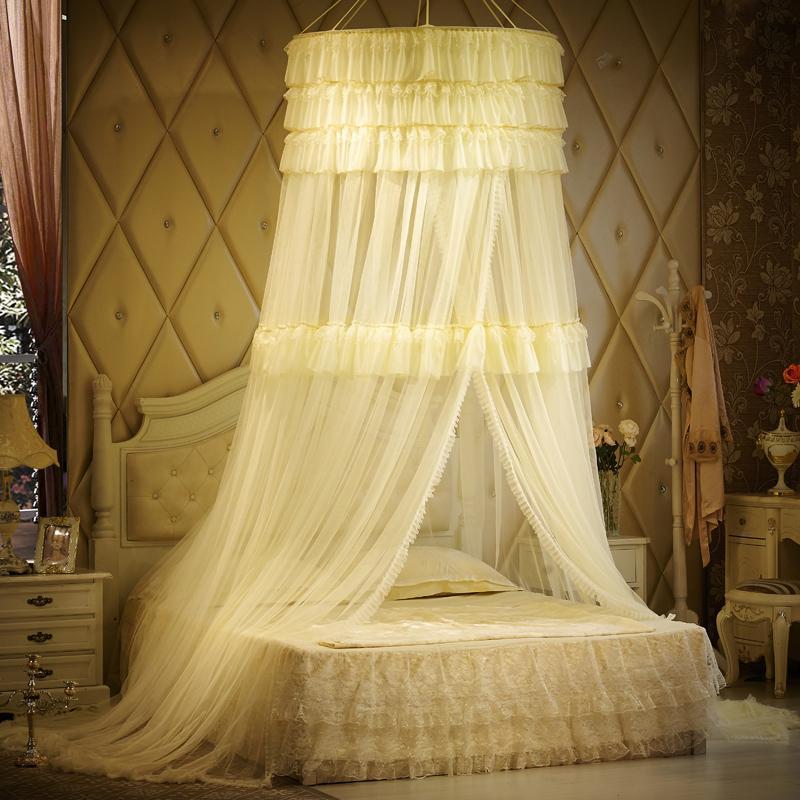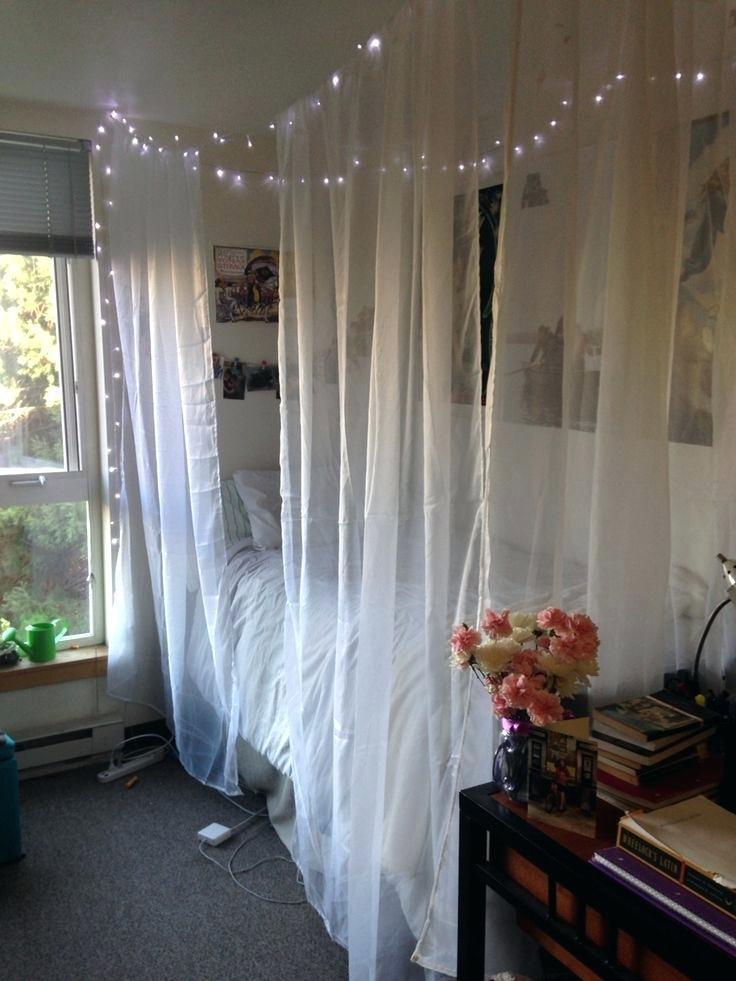The first image is the image on the left, the second image is the image on the right. For the images displayed, is the sentence "In one image, a bed is shown with a lacy, tiered yellow gold bedspread with matching draperies overhead." factually correct? Answer yes or no. Yes. 